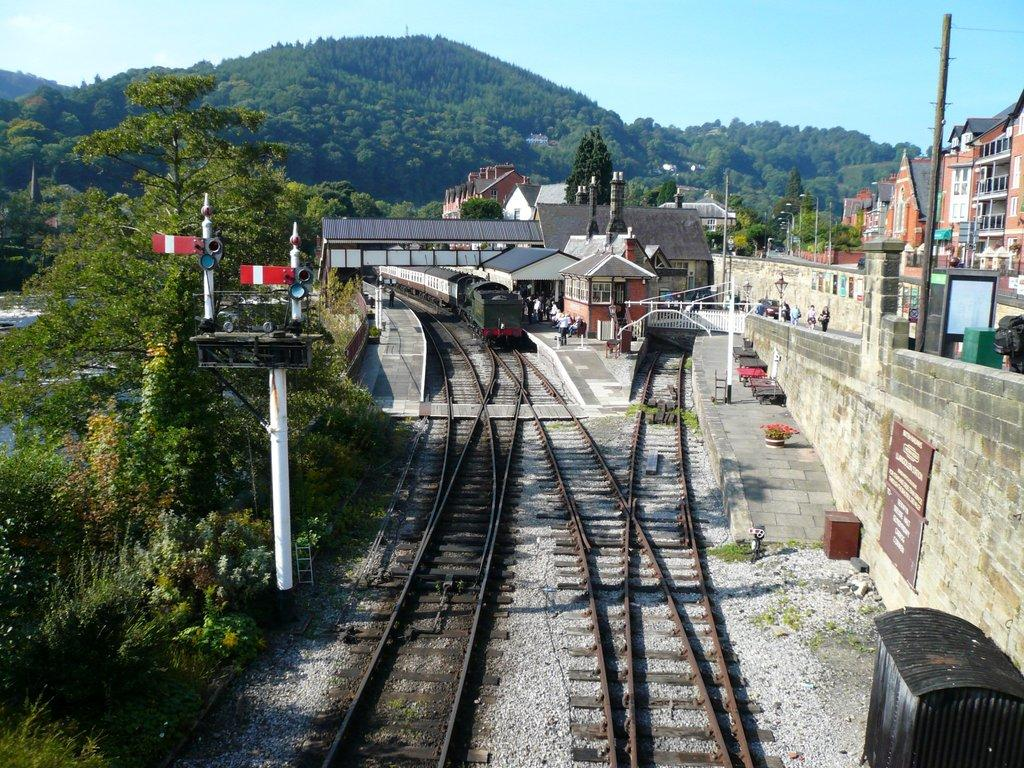What is the main subject of the image? The main subject of the image is a train on a railway track. What can be seen in the background of the image? There are mountains and the sky visible in the background of the image. What type of structures are present in the image? There are buildings and poles in the image. What is the location of the people in the image? The people are standing on a platform in the image. What type of adjustment can be seen being made to the wire in the image? There is no wire present in the image, so no adjustment can be observed. 